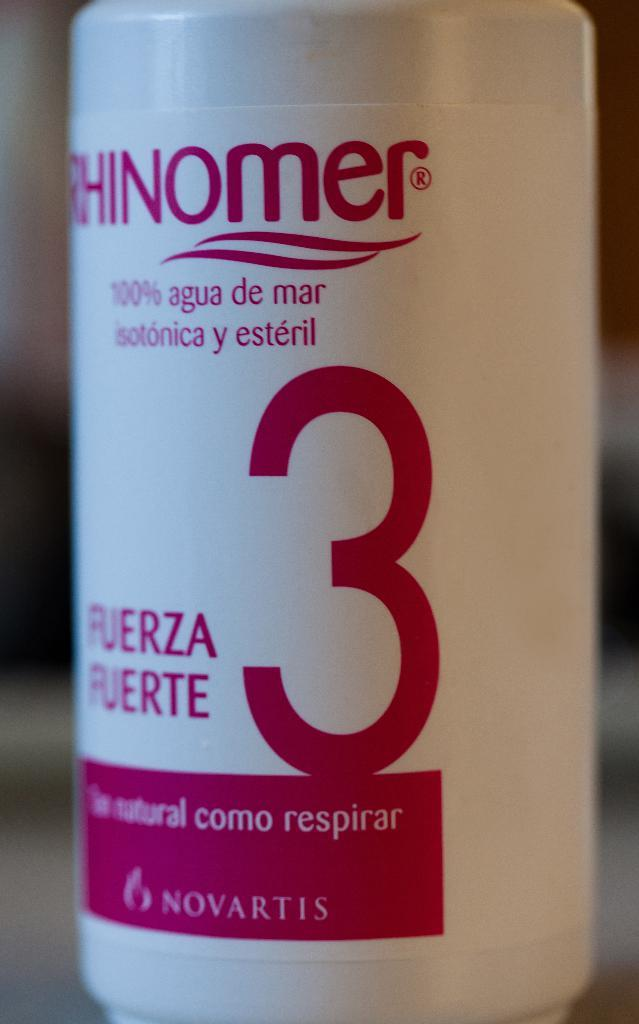<image>
Create a compact narrative representing the image presented. A product in a plastic white bottle bears a large red 3 on the side. 